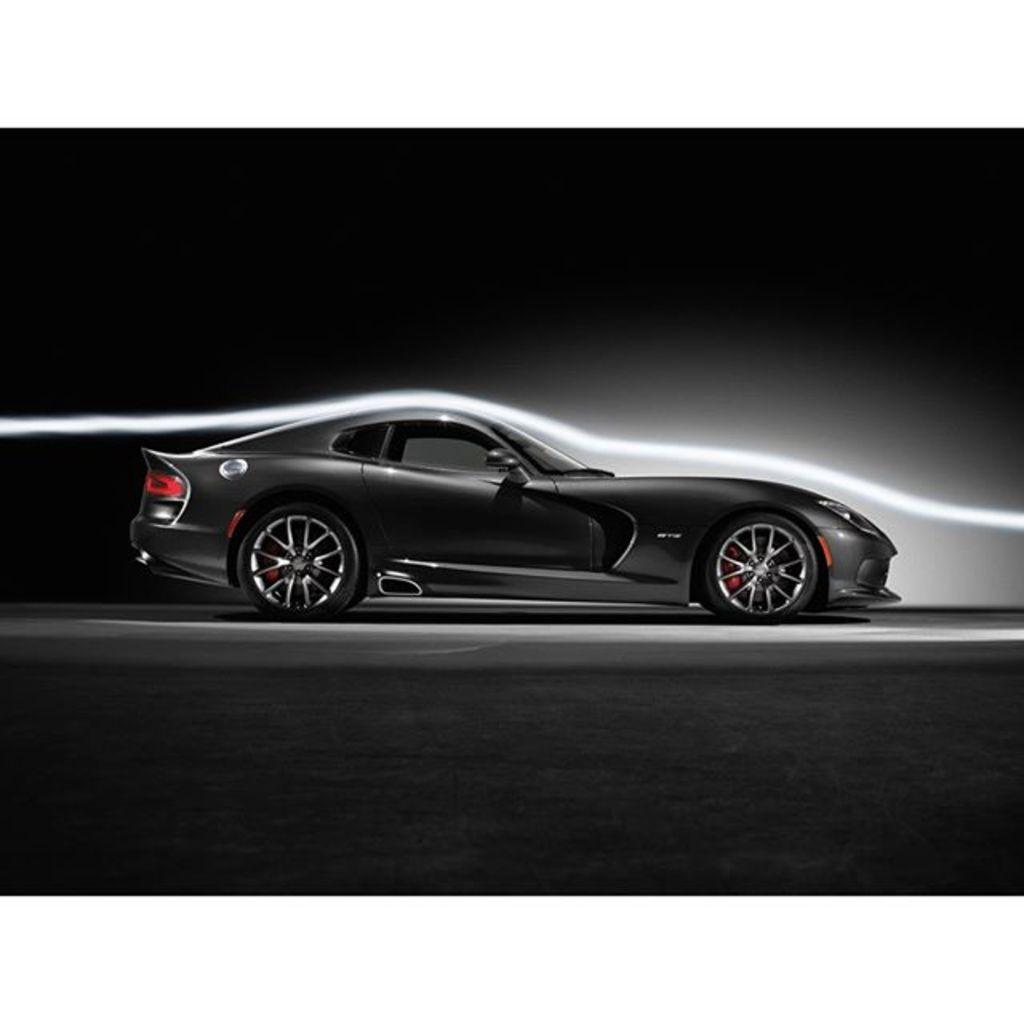What type of image is being described? The image is a graphical image. What is the color of the background in the image? The background of the image is dark. What is the main subject of the image? There is a car in the middle of the image. What is the color of the car in the image? The car is black in color. How many points does the car have in the image? The image does not depict points on the car; it is a graphical representation of a car. Can you describe the crook in the image? There is no crook present in the image. 